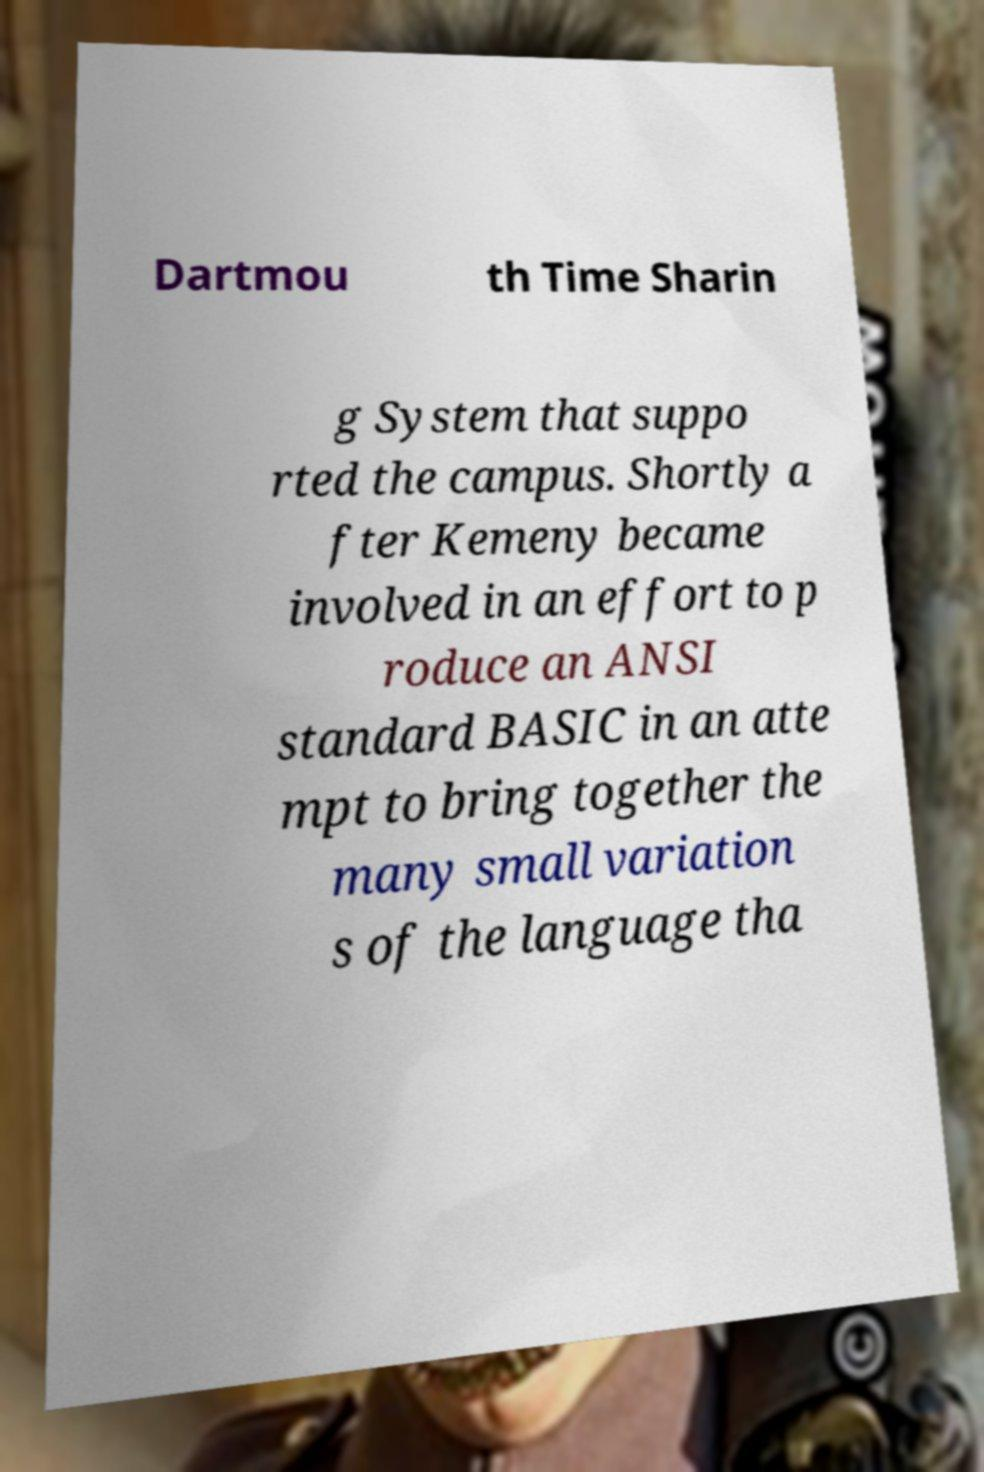I need the written content from this picture converted into text. Can you do that? Dartmou th Time Sharin g System that suppo rted the campus. Shortly a fter Kemeny became involved in an effort to p roduce an ANSI standard BASIC in an atte mpt to bring together the many small variation s of the language tha 